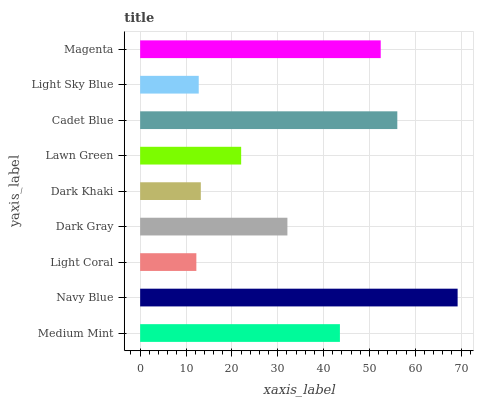Is Light Coral the minimum?
Answer yes or no. Yes. Is Navy Blue the maximum?
Answer yes or no. Yes. Is Navy Blue the minimum?
Answer yes or no. No. Is Light Coral the maximum?
Answer yes or no. No. Is Navy Blue greater than Light Coral?
Answer yes or no. Yes. Is Light Coral less than Navy Blue?
Answer yes or no. Yes. Is Light Coral greater than Navy Blue?
Answer yes or no. No. Is Navy Blue less than Light Coral?
Answer yes or no. No. Is Dark Gray the high median?
Answer yes or no. Yes. Is Dark Gray the low median?
Answer yes or no. Yes. Is Light Coral the high median?
Answer yes or no. No. Is Light Sky Blue the low median?
Answer yes or no. No. 